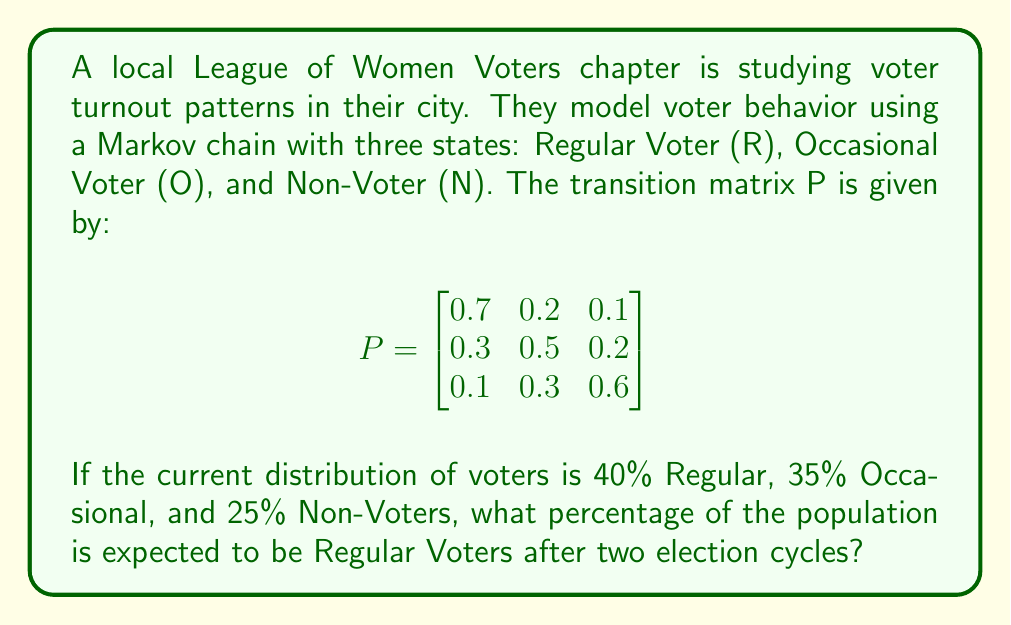Teach me how to tackle this problem. Let's approach this step-by-step:

1) First, we need to represent the initial distribution as a row vector:
   $\pi_0 = [0.4 \quad 0.35 \quad 0.25]$

2) To find the distribution after two election cycles, we need to multiply this initial distribution by the transition matrix P twice:
   $\pi_2 = \pi_0 P^2$

3) Let's calculate $P^2$ first:
   $$P^2 = \begin{bmatrix}
   0.7 & 0.2 & 0.1 \\
   0.3 & 0.5 & 0.2 \\
   0.1 & 0.3 & 0.6
   \end{bmatrix} \times 
   \begin{bmatrix}
   0.7 & 0.2 & 0.1 \\
   0.3 & 0.5 & 0.2 \\
   0.1 & 0.3 & 0.6
   \end{bmatrix}$$

4) Multiplying these matrices:
   $$P^2 = \begin{bmatrix}
   0.56 & 0.27 & 0.17 \\
   0.40 & 0.37 & 0.23 \\
   0.22 & 0.36 & 0.42
   \end{bmatrix}$$

5) Now, we multiply $\pi_0$ by $P^2$:
   $\pi_2 = [0.4 \quad 0.35 \quad 0.25] \times 
   \begin{bmatrix}
   0.56 & 0.27 & 0.17 \\
   0.40 & 0.37 & 0.23 \\
   0.22 & 0.36 & 0.42
   \end{bmatrix}$

6) Performing this multiplication:
   $\pi_2 = [0.4(0.56) + 0.35(0.40) + 0.25(0.22) \quad \ldots \quad \ldots]$

7) Calculating the first element (which represents Regular Voters):
   $0.4(0.56) + 0.35(0.40) + 0.25(0.22) = 0.224 + 0.140 + 0.055 = 0.419$

8) Therefore, after two election cycles, approximately 41.9% of the population is expected to be Regular Voters.
Answer: 41.9% 